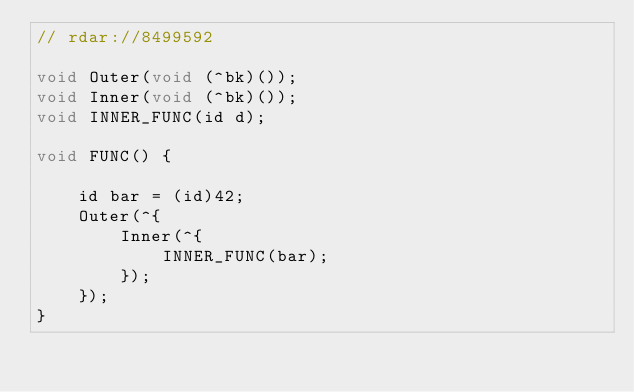Convert code to text. <code><loc_0><loc_0><loc_500><loc_500><_ObjectiveC_>// rdar://8499592

void Outer(void (^bk)());
void Inner(void (^bk)());
void INNER_FUNC(id d);

void FUNC() {
    
    id bar = (id)42;
    Outer(^{
        Inner(^{
            INNER_FUNC(bar);
        });
    });    
}
</code> 